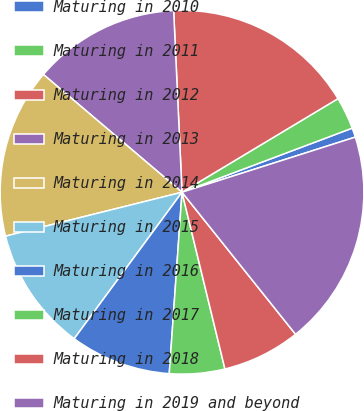Convert chart to OTSL. <chart><loc_0><loc_0><loc_500><loc_500><pie_chart><fcel>Maturing in 2010<fcel>Maturing in 2011<fcel>Maturing in 2012<fcel>Maturing in 2013<fcel>Maturing in 2014<fcel>Maturing in 2015<fcel>Maturing in 2016<fcel>Maturing in 2017<fcel>Maturing in 2018<fcel>Maturing in 2019 and beyond<nl><fcel>0.83%<fcel>2.87%<fcel>17.13%<fcel>13.06%<fcel>15.09%<fcel>11.02%<fcel>8.98%<fcel>4.91%<fcel>6.94%<fcel>19.17%<nl></chart> 